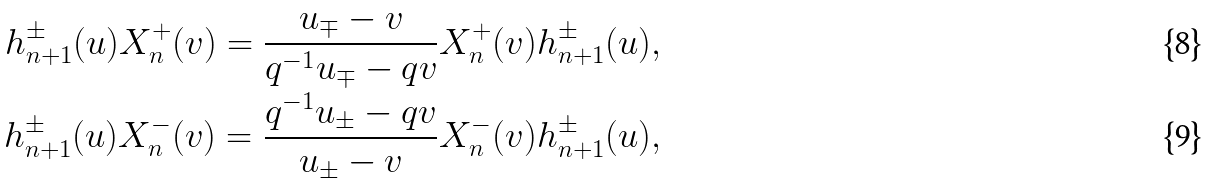Convert formula to latex. <formula><loc_0><loc_0><loc_500><loc_500>h _ { n + 1 } ^ { \pm } ( u ) X _ { n } ^ { + } ( v ) = \frac { u _ { \mp } - v } { q ^ { - 1 } u _ { \mp } - q v } X _ { n } ^ { + } ( v ) h _ { n + 1 } ^ { \pm } ( u ) , \\ h _ { n + 1 } ^ { \pm } ( u ) X _ { n } ^ { - } ( v ) = \frac { q ^ { - 1 } u _ { \pm } - q v } { u _ { \pm } - v } X _ { n } ^ { - } ( v ) h _ { n + 1 } ^ { \pm } ( u ) ,</formula> 